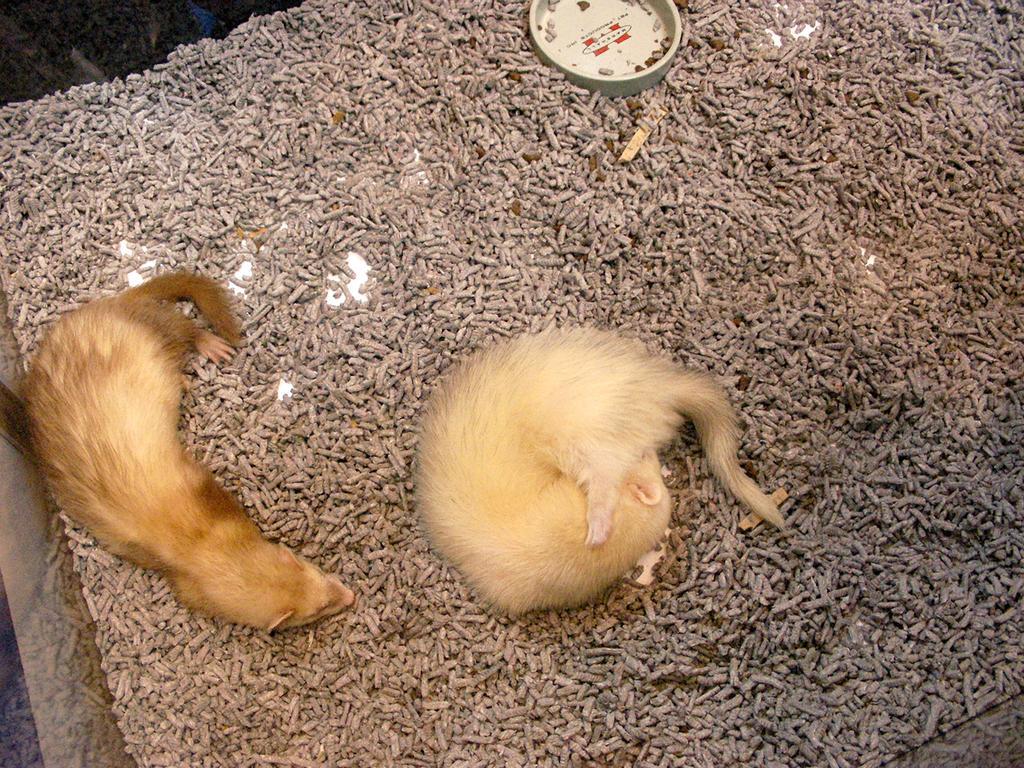In one or two sentences, can you explain what this image depicts? In this image there are two animals, there are objects on the ground, there is are objects truncated towards the top of the image, there are objects truncated towards the right of the image, there are object truncated towards the bottom of the image, there are objects truncated towards the left of the image. 